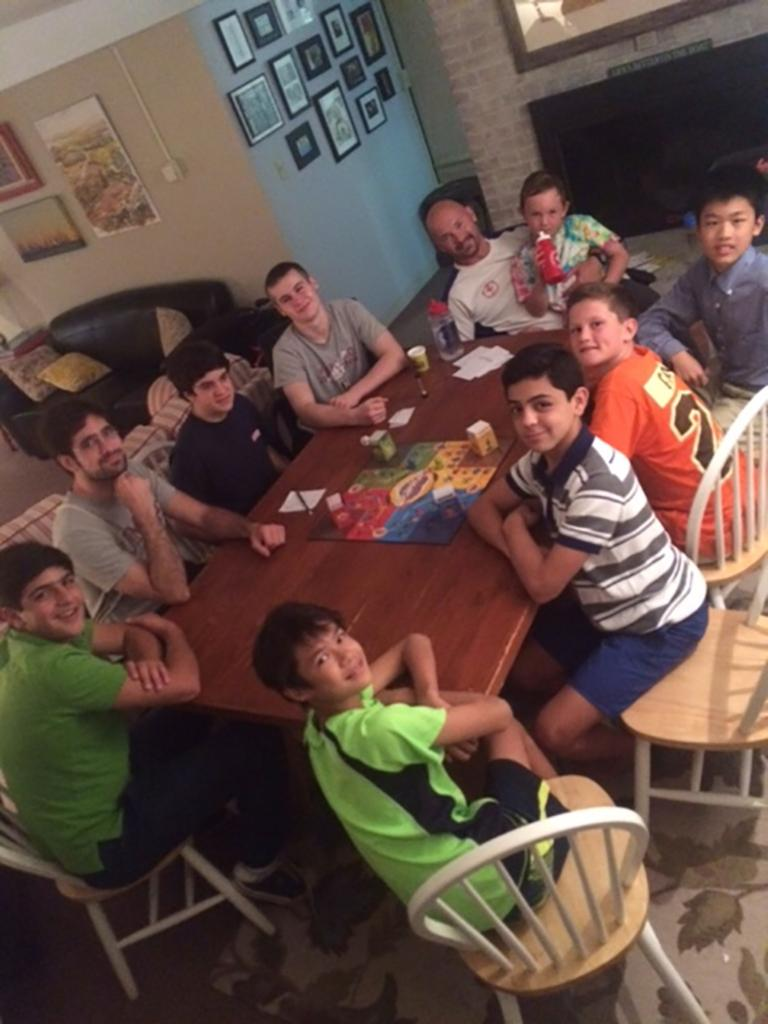What are the people in the image doing? The people in the image are sitting around a table. What are the people sitting on? The people are sitting in chairs. What is on the table in the image? A game is placed on the table. What can be seen in the background of the image? There is a wall in the background. What is attached to the wall in the image? Photographs are attached to the wall. Reasoning: Let'g: Let's think step by step in order to produce the conversation. We start by identifying the main activity of the people in the image, which is sitting around a table. Then, we describe the objects they are using, such as chairs. Next, we focus on the items on the table, which is a game. Finally, we mention the background elements, including the wall and photographs. Absurd Question/Answer: What type of dinosaurs can be seen playing with the kitty in the image? There are no dinosaurs or kitties present in the image. What type of lettuce is being used as a tablecloth in the image? There is no lettuce used as a tablecloth in the image; the table has a game on it. 